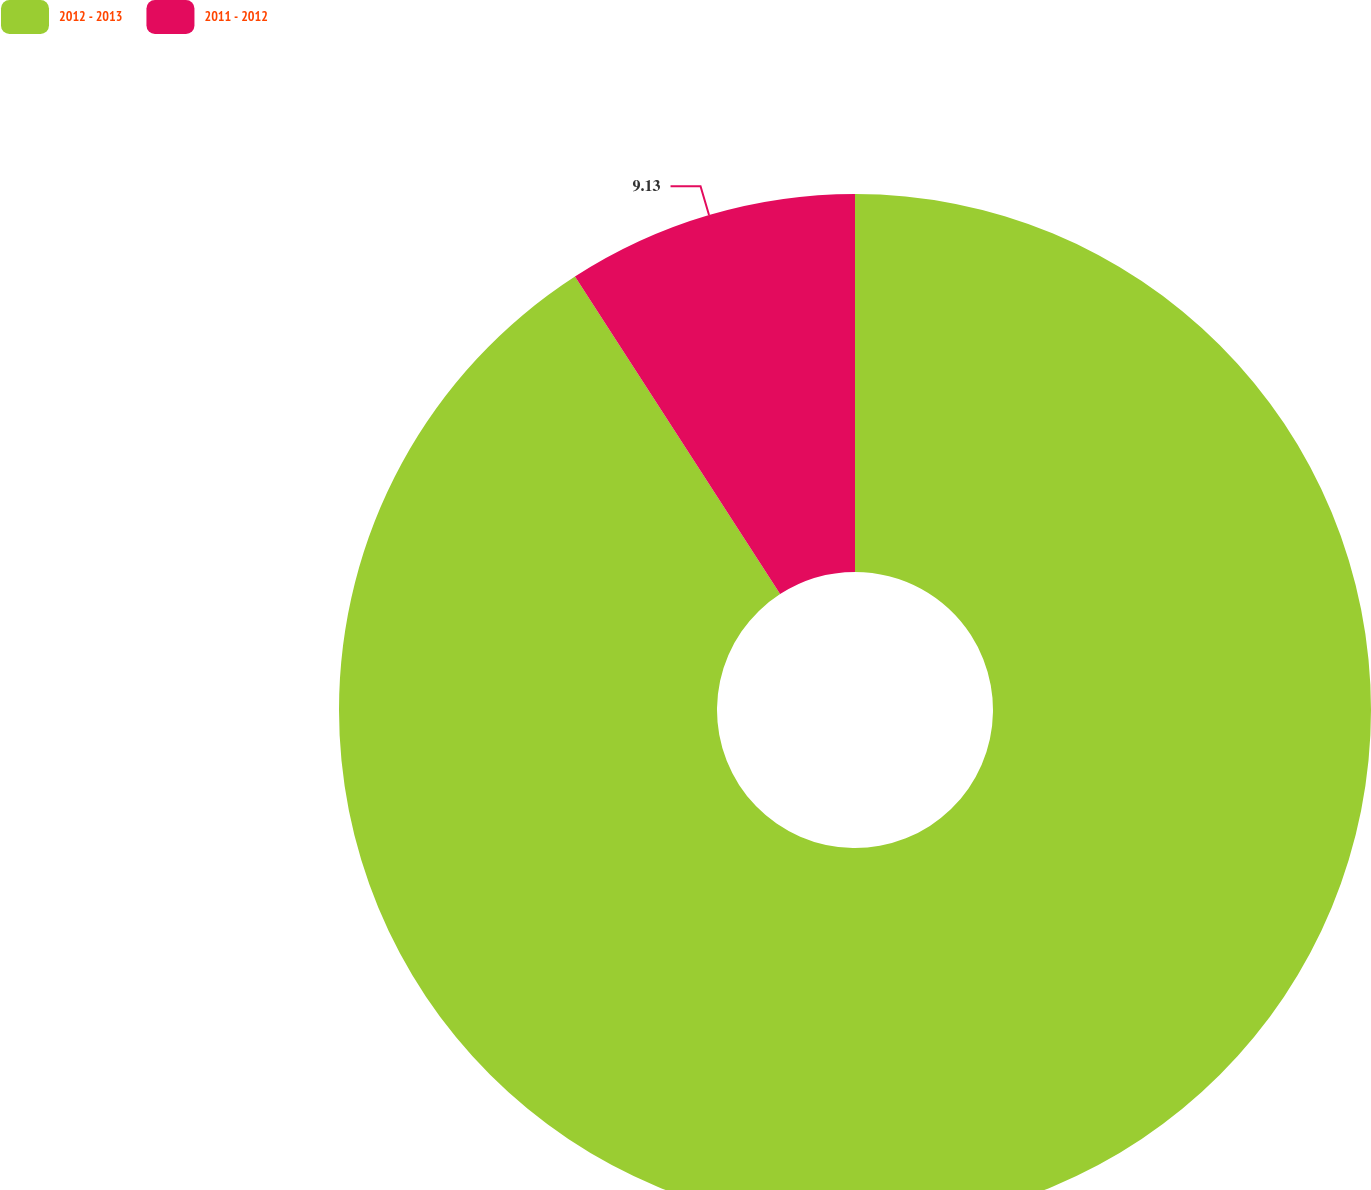Convert chart. <chart><loc_0><loc_0><loc_500><loc_500><pie_chart><fcel>2012 - 2013<fcel>2011 - 2012<nl><fcel>90.87%<fcel>9.13%<nl></chart> 